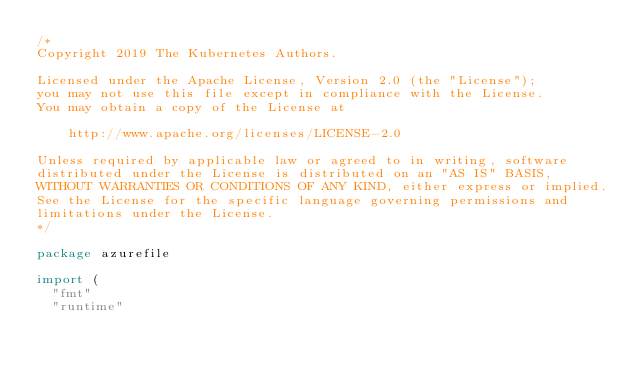Convert code to text. <code><loc_0><loc_0><loc_500><loc_500><_Go_>/*
Copyright 2019 The Kubernetes Authors.

Licensed under the Apache License, Version 2.0 (the "License");
you may not use this file except in compliance with the License.
You may obtain a copy of the License at

    http://www.apache.org/licenses/LICENSE-2.0

Unless required by applicable law or agreed to in writing, software
distributed under the License is distributed on an "AS IS" BASIS,
WITHOUT WARRANTIES OR CONDITIONS OF ANY KIND, either express or implied.
See the License for the specific language governing permissions and
limitations under the License.
*/

package azurefile

import (
	"fmt"
	"runtime"</code> 